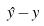Convert formula to latex. <formula><loc_0><loc_0><loc_500><loc_500>\hat { y } - y</formula> 